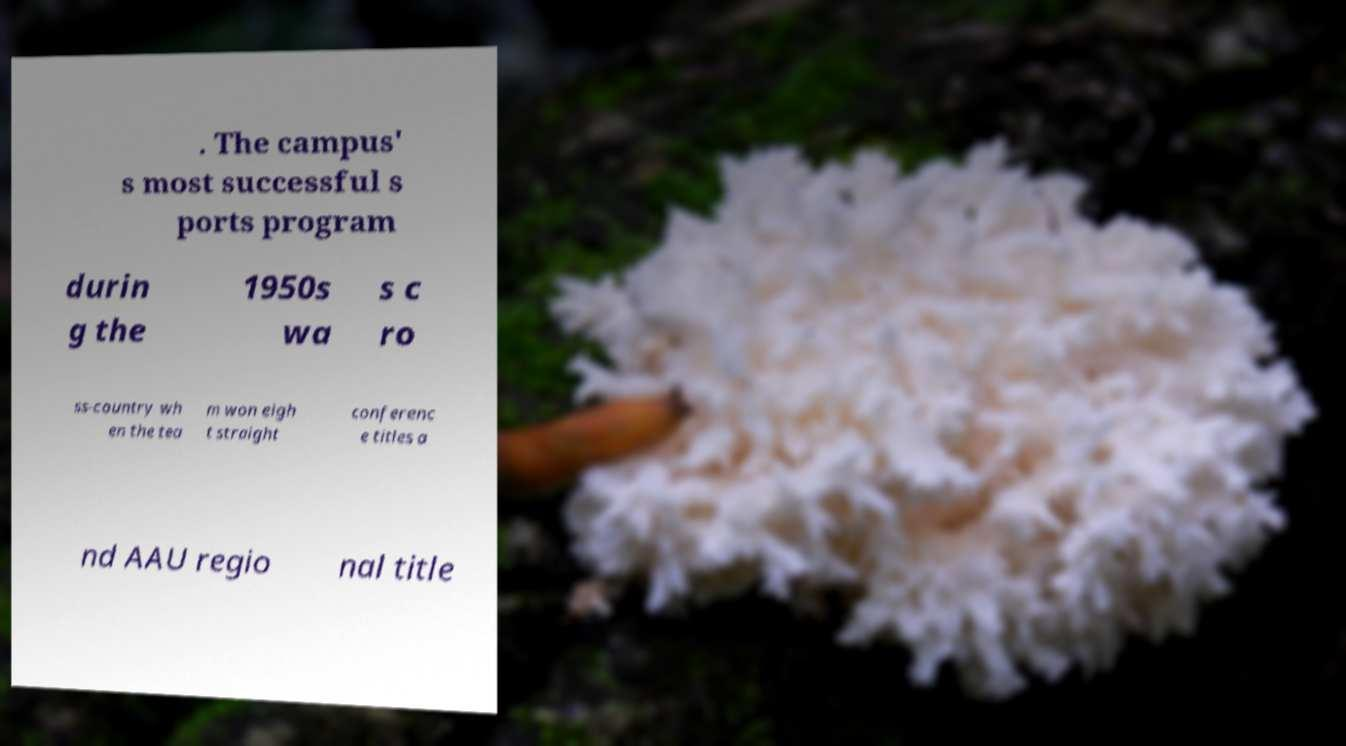Can you read and provide the text displayed in the image?This photo seems to have some interesting text. Can you extract and type it out for me? . The campus' s most successful s ports program durin g the 1950s wa s c ro ss-country wh en the tea m won eigh t straight conferenc e titles a nd AAU regio nal title 